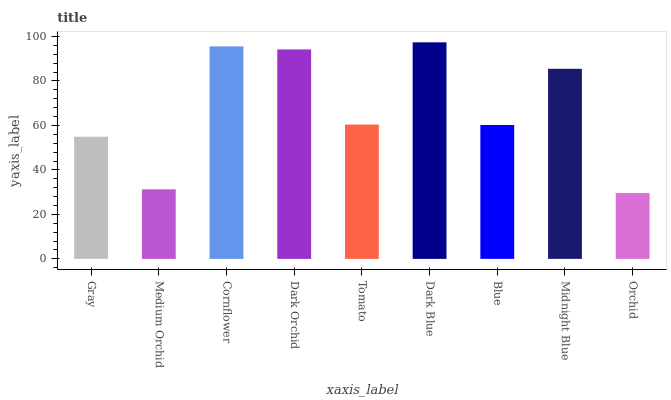Is Medium Orchid the minimum?
Answer yes or no. No. Is Medium Orchid the maximum?
Answer yes or no. No. Is Gray greater than Medium Orchid?
Answer yes or no. Yes. Is Medium Orchid less than Gray?
Answer yes or no. Yes. Is Medium Orchid greater than Gray?
Answer yes or no. No. Is Gray less than Medium Orchid?
Answer yes or no. No. Is Tomato the high median?
Answer yes or no. Yes. Is Tomato the low median?
Answer yes or no. Yes. Is Midnight Blue the high median?
Answer yes or no. No. Is Gray the low median?
Answer yes or no. No. 